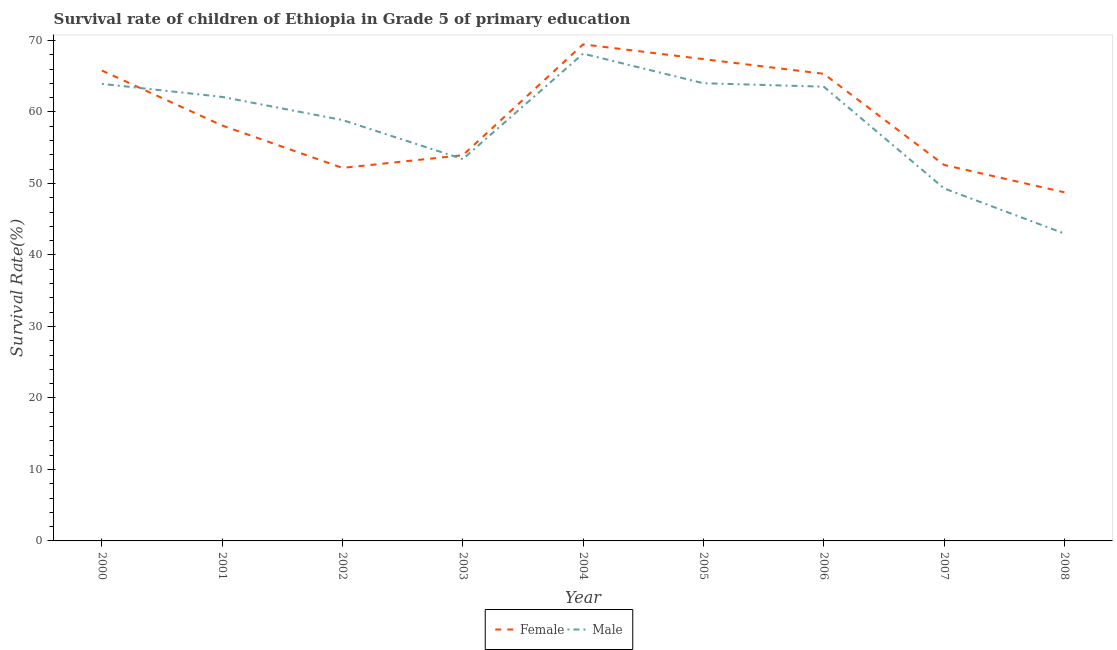What is the survival rate of female students in primary education in 2007?
Keep it short and to the point. 52.59. Across all years, what is the maximum survival rate of female students in primary education?
Ensure brevity in your answer.  69.46. Across all years, what is the minimum survival rate of female students in primary education?
Your answer should be compact. 48.77. In which year was the survival rate of female students in primary education maximum?
Give a very brief answer. 2004. In which year was the survival rate of female students in primary education minimum?
Offer a very short reply. 2008. What is the total survival rate of female students in primary education in the graph?
Offer a very short reply. 533.59. What is the difference between the survival rate of female students in primary education in 2002 and that in 2005?
Your answer should be very brief. -15.21. What is the difference between the survival rate of male students in primary education in 2005 and the survival rate of female students in primary education in 2000?
Your answer should be very brief. -1.78. What is the average survival rate of male students in primary education per year?
Make the answer very short. 58.48. In the year 2006, what is the difference between the survival rate of male students in primary education and survival rate of female students in primary education?
Give a very brief answer. -1.8. What is the ratio of the survival rate of female students in primary education in 2003 to that in 2005?
Provide a succinct answer. 0.8. Is the survival rate of female students in primary education in 2000 less than that in 2007?
Your answer should be compact. No. Is the difference between the survival rate of female students in primary education in 2005 and 2008 greater than the difference between the survival rate of male students in primary education in 2005 and 2008?
Keep it short and to the point. No. What is the difference between the highest and the second highest survival rate of female students in primary education?
Ensure brevity in your answer.  2.07. What is the difference between the highest and the lowest survival rate of female students in primary education?
Provide a short and direct response. 20.7. Is the survival rate of male students in primary education strictly greater than the survival rate of female students in primary education over the years?
Give a very brief answer. No. Does the graph contain grids?
Provide a succinct answer. No. How are the legend labels stacked?
Provide a succinct answer. Horizontal. What is the title of the graph?
Provide a succinct answer. Survival rate of children of Ethiopia in Grade 5 of primary education. Does "Male" appear as one of the legend labels in the graph?
Offer a very short reply. Yes. What is the label or title of the Y-axis?
Provide a succinct answer. Survival Rate(%). What is the Survival Rate(%) of Female in 2000?
Provide a succinct answer. 65.8. What is the Survival Rate(%) in Male in 2000?
Offer a very short reply. 63.94. What is the Survival Rate(%) in Female in 2001?
Your answer should be very brief. 58.11. What is the Survival Rate(%) in Male in 2001?
Make the answer very short. 62.11. What is the Survival Rate(%) in Female in 2002?
Provide a succinct answer. 52.18. What is the Survival Rate(%) of Male in 2002?
Make the answer very short. 58.87. What is the Survival Rate(%) of Female in 2003?
Make the answer very short. 53.95. What is the Survival Rate(%) in Male in 2003?
Give a very brief answer. 53.41. What is the Survival Rate(%) in Female in 2004?
Your answer should be compact. 69.46. What is the Survival Rate(%) in Male in 2004?
Offer a very short reply. 68.16. What is the Survival Rate(%) of Female in 2005?
Keep it short and to the point. 67.39. What is the Survival Rate(%) of Male in 2005?
Your answer should be very brief. 64.02. What is the Survival Rate(%) of Female in 2006?
Your answer should be compact. 65.34. What is the Survival Rate(%) of Male in 2006?
Give a very brief answer. 63.54. What is the Survival Rate(%) in Female in 2007?
Your answer should be compact. 52.59. What is the Survival Rate(%) of Male in 2007?
Make the answer very short. 49.31. What is the Survival Rate(%) of Female in 2008?
Provide a succinct answer. 48.77. What is the Survival Rate(%) in Male in 2008?
Your response must be concise. 43. Across all years, what is the maximum Survival Rate(%) of Female?
Offer a terse response. 69.46. Across all years, what is the maximum Survival Rate(%) of Male?
Your answer should be compact. 68.16. Across all years, what is the minimum Survival Rate(%) of Female?
Ensure brevity in your answer.  48.77. Across all years, what is the minimum Survival Rate(%) in Male?
Provide a short and direct response. 43. What is the total Survival Rate(%) of Female in the graph?
Your response must be concise. 533.59. What is the total Survival Rate(%) of Male in the graph?
Offer a terse response. 526.35. What is the difference between the Survival Rate(%) in Female in 2000 and that in 2001?
Your response must be concise. 7.69. What is the difference between the Survival Rate(%) of Male in 2000 and that in 2001?
Provide a short and direct response. 1.83. What is the difference between the Survival Rate(%) of Female in 2000 and that in 2002?
Keep it short and to the point. 13.62. What is the difference between the Survival Rate(%) in Male in 2000 and that in 2002?
Offer a terse response. 5.06. What is the difference between the Survival Rate(%) in Female in 2000 and that in 2003?
Provide a succinct answer. 11.85. What is the difference between the Survival Rate(%) in Male in 2000 and that in 2003?
Keep it short and to the point. 10.52. What is the difference between the Survival Rate(%) of Female in 2000 and that in 2004?
Your answer should be compact. -3.66. What is the difference between the Survival Rate(%) in Male in 2000 and that in 2004?
Your answer should be compact. -4.22. What is the difference between the Survival Rate(%) in Female in 2000 and that in 2005?
Offer a very short reply. -1.59. What is the difference between the Survival Rate(%) of Male in 2000 and that in 2005?
Your answer should be very brief. -0.08. What is the difference between the Survival Rate(%) of Female in 2000 and that in 2006?
Make the answer very short. 0.46. What is the difference between the Survival Rate(%) of Male in 2000 and that in 2006?
Make the answer very short. 0.39. What is the difference between the Survival Rate(%) in Female in 2000 and that in 2007?
Provide a succinct answer. 13.2. What is the difference between the Survival Rate(%) of Male in 2000 and that in 2007?
Offer a very short reply. 14.62. What is the difference between the Survival Rate(%) of Female in 2000 and that in 2008?
Make the answer very short. 17.03. What is the difference between the Survival Rate(%) of Male in 2000 and that in 2008?
Ensure brevity in your answer.  20.94. What is the difference between the Survival Rate(%) in Female in 2001 and that in 2002?
Ensure brevity in your answer.  5.93. What is the difference between the Survival Rate(%) of Male in 2001 and that in 2002?
Make the answer very short. 3.24. What is the difference between the Survival Rate(%) in Female in 2001 and that in 2003?
Provide a short and direct response. 4.16. What is the difference between the Survival Rate(%) of Male in 2001 and that in 2003?
Offer a terse response. 8.7. What is the difference between the Survival Rate(%) in Female in 2001 and that in 2004?
Provide a short and direct response. -11.35. What is the difference between the Survival Rate(%) in Male in 2001 and that in 2004?
Your answer should be very brief. -6.05. What is the difference between the Survival Rate(%) in Female in 2001 and that in 2005?
Offer a very short reply. -9.28. What is the difference between the Survival Rate(%) in Male in 2001 and that in 2005?
Provide a succinct answer. -1.91. What is the difference between the Survival Rate(%) in Female in 2001 and that in 2006?
Your answer should be compact. -7.23. What is the difference between the Survival Rate(%) of Male in 2001 and that in 2006?
Give a very brief answer. -1.43. What is the difference between the Survival Rate(%) of Female in 2001 and that in 2007?
Offer a very short reply. 5.52. What is the difference between the Survival Rate(%) of Male in 2001 and that in 2007?
Your answer should be compact. 12.8. What is the difference between the Survival Rate(%) of Female in 2001 and that in 2008?
Your answer should be very brief. 9.34. What is the difference between the Survival Rate(%) in Male in 2001 and that in 2008?
Give a very brief answer. 19.11. What is the difference between the Survival Rate(%) in Female in 2002 and that in 2003?
Your answer should be very brief. -1.77. What is the difference between the Survival Rate(%) in Male in 2002 and that in 2003?
Provide a succinct answer. 5.46. What is the difference between the Survival Rate(%) of Female in 2002 and that in 2004?
Ensure brevity in your answer.  -17.28. What is the difference between the Survival Rate(%) in Male in 2002 and that in 2004?
Keep it short and to the point. -9.29. What is the difference between the Survival Rate(%) of Female in 2002 and that in 2005?
Keep it short and to the point. -15.21. What is the difference between the Survival Rate(%) in Male in 2002 and that in 2005?
Offer a terse response. -5.15. What is the difference between the Survival Rate(%) in Female in 2002 and that in 2006?
Offer a terse response. -13.16. What is the difference between the Survival Rate(%) in Male in 2002 and that in 2006?
Offer a very short reply. -4.67. What is the difference between the Survival Rate(%) of Female in 2002 and that in 2007?
Your response must be concise. -0.42. What is the difference between the Survival Rate(%) of Male in 2002 and that in 2007?
Make the answer very short. 9.56. What is the difference between the Survival Rate(%) of Female in 2002 and that in 2008?
Keep it short and to the point. 3.41. What is the difference between the Survival Rate(%) in Male in 2002 and that in 2008?
Offer a very short reply. 15.87. What is the difference between the Survival Rate(%) of Female in 2003 and that in 2004?
Offer a very short reply. -15.51. What is the difference between the Survival Rate(%) of Male in 2003 and that in 2004?
Provide a succinct answer. -14.75. What is the difference between the Survival Rate(%) in Female in 2003 and that in 2005?
Make the answer very short. -13.44. What is the difference between the Survival Rate(%) of Male in 2003 and that in 2005?
Your answer should be compact. -10.61. What is the difference between the Survival Rate(%) in Female in 2003 and that in 2006?
Make the answer very short. -11.39. What is the difference between the Survival Rate(%) of Male in 2003 and that in 2006?
Make the answer very short. -10.13. What is the difference between the Survival Rate(%) in Female in 2003 and that in 2007?
Provide a short and direct response. 1.36. What is the difference between the Survival Rate(%) in Male in 2003 and that in 2007?
Give a very brief answer. 4.1. What is the difference between the Survival Rate(%) of Female in 2003 and that in 2008?
Your answer should be very brief. 5.18. What is the difference between the Survival Rate(%) in Male in 2003 and that in 2008?
Your answer should be compact. 10.41. What is the difference between the Survival Rate(%) in Female in 2004 and that in 2005?
Offer a terse response. 2.07. What is the difference between the Survival Rate(%) of Male in 2004 and that in 2005?
Keep it short and to the point. 4.14. What is the difference between the Survival Rate(%) in Female in 2004 and that in 2006?
Give a very brief answer. 4.12. What is the difference between the Survival Rate(%) of Male in 2004 and that in 2006?
Make the answer very short. 4.62. What is the difference between the Survival Rate(%) of Female in 2004 and that in 2007?
Your response must be concise. 16.87. What is the difference between the Survival Rate(%) in Male in 2004 and that in 2007?
Ensure brevity in your answer.  18.84. What is the difference between the Survival Rate(%) of Female in 2004 and that in 2008?
Make the answer very short. 20.7. What is the difference between the Survival Rate(%) of Male in 2004 and that in 2008?
Your response must be concise. 25.16. What is the difference between the Survival Rate(%) in Female in 2005 and that in 2006?
Your answer should be very brief. 2.05. What is the difference between the Survival Rate(%) of Male in 2005 and that in 2006?
Make the answer very short. 0.48. What is the difference between the Survival Rate(%) in Female in 2005 and that in 2007?
Your response must be concise. 14.8. What is the difference between the Survival Rate(%) of Male in 2005 and that in 2007?
Offer a very short reply. 14.71. What is the difference between the Survival Rate(%) of Female in 2005 and that in 2008?
Ensure brevity in your answer.  18.62. What is the difference between the Survival Rate(%) of Male in 2005 and that in 2008?
Make the answer very short. 21.02. What is the difference between the Survival Rate(%) of Female in 2006 and that in 2007?
Make the answer very short. 12.75. What is the difference between the Survival Rate(%) in Male in 2006 and that in 2007?
Your answer should be compact. 14.23. What is the difference between the Survival Rate(%) of Female in 2006 and that in 2008?
Your response must be concise. 16.57. What is the difference between the Survival Rate(%) in Male in 2006 and that in 2008?
Make the answer very short. 20.54. What is the difference between the Survival Rate(%) of Female in 2007 and that in 2008?
Offer a terse response. 3.83. What is the difference between the Survival Rate(%) in Male in 2007 and that in 2008?
Your answer should be very brief. 6.31. What is the difference between the Survival Rate(%) in Female in 2000 and the Survival Rate(%) in Male in 2001?
Provide a short and direct response. 3.69. What is the difference between the Survival Rate(%) of Female in 2000 and the Survival Rate(%) of Male in 2002?
Make the answer very short. 6.93. What is the difference between the Survival Rate(%) in Female in 2000 and the Survival Rate(%) in Male in 2003?
Make the answer very short. 12.39. What is the difference between the Survival Rate(%) of Female in 2000 and the Survival Rate(%) of Male in 2004?
Give a very brief answer. -2.36. What is the difference between the Survival Rate(%) in Female in 2000 and the Survival Rate(%) in Male in 2005?
Provide a succinct answer. 1.78. What is the difference between the Survival Rate(%) of Female in 2000 and the Survival Rate(%) of Male in 2006?
Provide a short and direct response. 2.26. What is the difference between the Survival Rate(%) of Female in 2000 and the Survival Rate(%) of Male in 2007?
Offer a very short reply. 16.49. What is the difference between the Survival Rate(%) of Female in 2000 and the Survival Rate(%) of Male in 2008?
Offer a very short reply. 22.8. What is the difference between the Survival Rate(%) in Female in 2001 and the Survival Rate(%) in Male in 2002?
Make the answer very short. -0.76. What is the difference between the Survival Rate(%) of Female in 2001 and the Survival Rate(%) of Male in 2003?
Give a very brief answer. 4.7. What is the difference between the Survival Rate(%) of Female in 2001 and the Survival Rate(%) of Male in 2004?
Provide a short and direct response. -10.04. What is the difference between the Survival Rate(%) in Female in 2001 and the Survival Rate(%) in Male in 2005?
Make the answer very short. -5.91. What is the difference between the Survival Rate(%) of Female in 2001 and the Survival Rate(%) of Male in 2006?
Offer a terse response. -5.43. What is the difference between the Survival Rate(%) in Female in 2001 and the Survival Rate(%) in Male in 2008?
Make the answer very short. 15.11. What is the difference between the Survival Rate(%) of Female in 2002 and the Survival Rate(%) of Male in 2003?
Give a very brief answer. -1.23. What is the difference between the Survival Rate(%) in Female in 2002 and the Survival Rate(%) in Male in 2004?
Provide a short and direct response. -15.98. What is the difference between the Survival Rate(%) of Female in 2002 and the Survival Rate(%) of Male in 2005?
Offer a terse response. -11.84. What is the difference between the Survival Rate(%) of Female in 2002 and the Survival Rate(%) of Male in 2006?
Give a very brief answer. -11.36. What is the difference between the Survival Rate(%) of Female in 2002 and the Survival Rate(%) of Male in 2007?
Provide a short and direct response. 2.87. What is the difference between the Survival Rate(%) in Female in 2002 and the Survival Rate(%) in Male in 2008?
Give a very brief answer. 9.18. What is the difference between the Survival Rate(%) in Female in 2003 and the Survival Rate(%) in Male in 2004?
Your answer should be compact. -14.21. What is the difference between the Survival Rate(%) of Female in 2003 and the Survival Rate(%) of Male in 2005?
Give a very brief answer. -10.07. What is the difference between the Survival Rate(%) of Female in 2003 and the Survival Rate(%) of Male in 2006?
Ensure brevity in your answer.  -9.59. What is the difference between the Survival Rate(%) in Female in 2003 and the Survival Rate(%) in Male in 2007?
Offer a very short reply. 4.64. What is the difference between the Survival Rate(%) of Female in 2003 and the Survival Rate(%) of Male in 2008?
Offer a very short reply. 10.95. What is the difference between the Survival Rate(%) of Female in 2004 and the Survival Rate(%) of Male in 2005?
Your response must be concise. 5.44. What is the difference between the Survival Rate(%) in Female in 2004 and the Survival Rate(%) in Male in 2006?
Ensure brevity in your answer.  5.92. What is the difference between the Survival Rate(%) of Female in 2004 and the Survival Rate(%) of Male in 2007?
Your answer should be very brief. 20.15. What is the difference between the Survival Rate(%) in Female in 2004 and the Survival Rate(%) in Male in 2008?
Provide a short and direct response. 26.46. What is the difference between the Survival Rate(%) in Female in 2005 and the Survival Rate(%) in Male in 2006?
Provide a short and direct response. 3.85. What is the difference between the Survival Rate(%) of Female in 2005 and the Survival Rate(%) of Male in 2007?
Your response must be concise. 18.08. What is the difference between the Survival Rate(%) of Female in 2005 and the Survival Rate(%) of Male in 2008?
Keep it short and to the point. 24.39. What is the difference between the Survival Rate(%) of Female in 2006 and the Survival Rate(%) of Male in 2007?
Offer a terse response. 16.03. What is the difference between the Survival Rate(%) of Female in 2006 and the Survival Rate(%) of Male in 2008?
Keep it short and to the point. 22.34. What is the difference between the Survival Rate(%) in Female in 2007 and the Survival Rate(%) in Male in 2008?
Keep it short and to the point. 9.6. What is the average Survival Rate(%) of Female per year?
Provide a succinct answer. 59.29. What is the average Survival Rate(%) in Male per year?
Your response must be concise. 58.48. In the year 2000, what is the difference between the Survival Rate(%) of Female and Survival Rate(%) of Male?
Offer a very short reply. 1.86. In the year 2001, what is the difference between the Survival Rate(%) in Female and Survival Rate(%) in Male?
Your response must be concise. -4. In the year 2002, what is the difference between the Survival Rate(%) of Female and Survival Rate(%) of Male?
Provide a succinct answer. -6.69. In the year 2003, what is the difference between the Survival Rate(%) in Female and Survival Rate(%) in Male?
Make the answer very short. 0.54. In the year 2004, what is the difference between the Survival Rate(%) in Female and Survival Rate(%) in Male?
Make the answer very short. 1.31. In the year 2005, what is the difference between the Survival Rate(%) in Female and Survival Rate(%) in Male?
Make the answer very short. 3.37. In the year 2007, what is the difference between the Survival Rate(%) in Female and Survival Rate(%) in Male?
Give a very brief answer. 3.28. In the year 2008, what is the difference between the Survival Rate(%) of Female and Survival Rate(%) of Male?
Your answer should be very brief. 5.77. What is the ratio of the Survival Rate(%) of Female in 2000 to that in 2001?
Provide a succinct answer. 1.13. What is the ratio of the Survival Rate(%) of Male in 2000 to that in 2001?
Ensure brevity in your answer.  1.03. What is the ratio of the Survival Rate(%) in Female in 2000 to that in 2002?
Offer a terse response. 1.26. What is the ratio of the Survival Rate(%) of Male in 2000 to that in 2002?
Ensure brevity in your answer.  1.09. What is the ratio of the Survival Rate(%) in Female in 2000 to that in 2003?
Your answer should be compact. 1.22. What is the ratio of the Survival Rate(%) in Male in 2000 to that in 2003?
Offer a terse response. 1.2. What is the ratio of the Survival Rate(%) of Female in 2000 to that in 2004?
Your answer should be very brief. 0.95. What is the ratio of the Survival Rate(%) in Male in 2000 to that in 2004?
Make the answer very short. 0.94. What is the ratio of the Survival Rate(%) of Female in 2000 to that in 2005?
Provide a short and direct response. 0.98. What is the ratio of the Survival Rate(%) in Male in 2000 to that in 2006?
Keep it short and to the point. 1.01. What is the ratio of the Survival Rate(%) of Female in 2000 to that in 2007?
Your response must be concise. 1.25. What is the ratio of the Survival Rate(%) in Male in 2000 to that in 2007?
Give a very brief answer. 1.3. What is the ratio of the Survival Rate(%) of Female in 2000 to that in 2008?
Your response must be concise. 1.35. What is the ratio of the Survival Rate(%) in Male in 2000 to that in 2008?
Make the answer very short. 1.49. What is the ratio of the Survival Rate(%) in Female in 2001 to that in 2002?
Give a very brief answer. 1.11. What is the ratio of the Survival Rate(%) of Male in 2001 to that in 2002?
Give a very brief answer. 1.05. What is the ratio of the Survival Rate(%) of Female in 2001 to that in 2003?
Make the answer very short. 1.08. What is the ratio of the Survival Rate(%) of Male in 2001 to that in 2003?
Make the answer very short. 1.16. What is the ratio of the Survival Rate(%) of Female in 2001 to that in 2004?
Your answer should be compact. 0.84. What is the ratio of the Survival Rate(%) in Male in 2001 to that in 2004?
Offer a terse response. 0.91. What is the ratio of the Survival Rate(%) of Female in 2001 to that in 2005?
Keep it short and to the point. 0.86. What is the ratio of the Survival Rate(%) of Male in 2001 to that in 2005?
Offer a terse response. 0.97. What is the ratio of the Survival Rate(%) of Female in 2001 to that in 2006?
Your answer should be compact. 0.89. What is the ratio of the Survival Rate(%) of Male in 2001 to that in 2006?
Make the answer very short. 0.98. What is the ratio of the Survival Rate(%) of Female in 2001 to that in 2007?
Provide a short and direct response. 1.1. What is the ratio of the Survival Rate(%) of Male in 2001 to that in 2007?
Keep it short and to the point. 1.26. What is the ratio of the Survival Rate(%) of Female in 2001 to that in 2008?
Make the answer very short. 1.19. What is the ratio of the Survival Rate(%) in Male in 2001 to that in 2008?
Your answer should be very brief. 1.44. What is the ratio of the Survival Rate(%) of Female in 2002 to that in 2003?
Provide a succinct answer. 0.97. What is the ratio of the Survival Rate(%) in Male in 2002 to that in 2003?
Make the answer very short. 1.1. What is the ratio of the Survival Rate(%) in Female in 2002 to that in 2004?
Provide a succinct answer. 0.75. What is the ratio of the Survival Rate(%) in Male in 2002 to that in 2004?
Your response must be concise. 0.86. What is the ratio of the Survival Rate(%) in Female in 2002 to that in 2005?
Ensure brevity in your answer.  0.77. What is the ratio of the Survival Rate(%) in Male in 2002 to that in 2005?
Your answer should be very brief. 0.92. What is the ratio of the Survival Rate(%) of Female in 2002 to that in 2006?
Your response must be concise. 0.8. What is the ratio of the Survival Rate(%) in Male in 2002 to that in 2006?
Give a very brief answer. 0.93. What is the ratio of the Survival Rate(%) in Male in 2002 to that in 2007?
Ensure brevity in your answer.  1.19. What is the ratio of the Survival Rate(%) in Female in 2002 to that in 2008?
Provide a short and direct response. 1.07. What is the ratio of the Survival Rate(%) in Male in 2002 to that in 2008?
Your answer should be very brief. 1.37. What is the ratio of the Survival Rate(%) of Female in 2003 to that in 2004?
Your answer should be very brief. 0.78. What is the ratio of the Survival Rate(%) in Male in 2003 to that in 2004?
Offer a terse response. 0.78. What is the ratio of the Survival Rate(%) in Female in 2003 to that in 2005?
Ensure brevity in your answer.  0.8. What is the ratio of the Survival Rate(%) of Male in 2003 to that in 2005?
Offer a very short reply. 0.83. What is the ratio of the Survival Rate(%) in Female in 2003 to that in 2006?
Offer a very short reply. 0.83. What is the ratio of the Survival Rate(%) of Male in 2003 to that in 2006?
Give a very brief answer. 0.84. What is the ratio of the Survival Rate(%) in Female in 2003 to that in 2007?
Provide a short and direct response. 1.03. What is the ratio of the Survival Rate(%) in Male in 2003 to that in 2007?
Keep it short and to the point. 1.08. What is the ratio of the Survival Rate(%) in Female in 2003 to that in 2008?
Provide a succinct answer. 1.11. What is the ratio of the Survival Rate(%) of Male in 2003 to that in 2008?
Provide a succinct answer. 1.24. What is the ratio of the Survival Rate(%) of Female in 2004 to that in 2005?
Keep it short and to the point. 1.03. What is the ratio of the Survival Rate(%) in Male in 2004 to that in 2005?
Your response must be concise. 1.06. What is the ratio of the Survival Rate(%) in Female in 2004 to that in 2006?
Your answer should be very brief. 1.06. What is the ratio of the Survival Rate(%) in Male in 2004 to that in 2006?
Provide a short and direct response. 1.07. What is the ratio of the Survival Rate(%) of Female in 2004 to that in 2007?
Provide a short and direct response. 1.32. What is the ratio of the Survival Rate(%) in Male in 2004 to that in 2007?
Provide a succinct answer. 1.38. What is the ratio of the Survival Rate(%) of Female in 2004 to that in 2008?
Offer a very short reply. 1.42. What is the ratio of the Survival Rate(%) in Male in 2004 to that in 2008?
Provide a succinct answer. 1.59. What is the ratio of the Survival Rate(%) of Female in 2005 to that in 2006?
Offer a terse response. 1.03. What is the ratio of the Survival Rate(%) in Male in 2005 to that in 2006?
Your answer should be compact. 1.01. What is the ratio of the Survival Rate(%) in Female in 2005 to that in 2007?
Offer a terse response. 1.28. What is the ratio of the Survival Rate(%) in Male in 2005 to that in 2007?
Provide a short and direct response. 1.3. What is the ratio of the Survival Rate(%) in Female in 2005 to that in 2008?
Your response must be concise. 1.38. What is the ratio of the Survival Rate(%) in Male in 2005 to that in 2008?
Make the answer very short. 1.49. What is the ratio of the Survival Rate(%) in Female in 2006 to that in 2007?
Give a very brief answer. 1.24. What is the ratio of the Survival Rate(%) of Male in 2006 to that in 2007?
Your answer should be very brief. 1.29. What is the ratio of the Survival Rate(%) in Female in 2006 to that in 2008?
Provide a short and direct response. 1.34. What is the ratio of the Survival Rate(%) in Male in 2006 to that in 2008?
Provide a succinct answer. 1.48. What is the ratio of the Survival Rate(%) of Female in 2007 to that in 2008?
Give a very brief answer. 1.08. What is the ratio of the Survival Rate(%) of Male in 2007 to that in 2008?
Your answer should be compact. 1.15. What is the difference between the highest and the second highest Survival Rate(%) in Female?
Offer a terse response. 2.07. What is the difference between the highest and the second highest Survival Rate(%) in Male?
Provide a succinct answer. 4.14. What is the difference between the highest and the lowest Survival Rate(%) of Female?
Provide a succinct answer. 20.7. What is the difference between the highest and the lowest Survival Rate(%) in Male?
Ensure brevity in your answer.  25.16. 